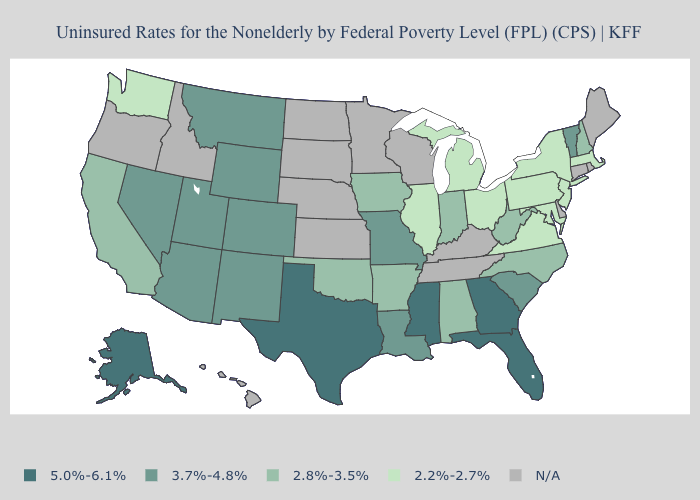Name the states that have a value in the range 3.7%-4.8%?
Short answer required. Arizona, Colorado, Louisiana, Missouri, Montana, Nevada, New Mexico, South Carolina, Utah, Vermont, Wyoming. Name the states that have a value in the range 2.2%-2.7%?
Short answer required. Illinois, Maryland, Massachusetts, Michigan, New Jersey, New York, Ohio, Pennsylvania, Virginia, Washington. What is the highest value in states that border Massachusetts?
Give a very brief answer. 3.7%-4.8%. What is the value of Connecticut?
Give a very brief answer. N/A. Does Colorado have the lowest value in the USA?
Give a very brief answer. No. Does Utah have the lowest value in the West?
Keep it brief. No. Which states have the highest value in the USA?
Concise answer only. Alaska, Florida, Georgia, Mississippi, Texas. Name the states that have a value in the range N/A?
Write a very short answer. Connecticut, Delaware, Hawaii, Idaho, Kansas, Kentucky, Maine, Minnesota, Nebraska, North Dakota, Oregon, Rhode Island, South Dakota, Tennessee, Wisconsin. Is the legend a continuous bar?
Write a very short answer. No. Name the states that have a value in the range 3.7%-4.8%?
Answer briefly. Arizona, Colorado, Louisiana, Missouri, Montana, Nevada, New Mexico, South Carolina, Utah, Vermont, Wyoming. Name the states that have a value in the range 2.8%-3.5%?
Short answer required. Alabama, Arkansas, California, Indiana, Iowa, New Hampshire, North Carolina, Oklahoma, West Virginia. Name the states that have a value in the range 2.2%-2.7%?
Write a very short answer. Illinois, Maryland, Massachusetts, Michigan, New Jersey, New York, Ohio, Pennsylvania, Virginia, Washington. Does Washington have the highest value in the West?
Concise answer only. No. Does Iowa have the lowest value in the MidWest?
Quick response, please. No. What is the lowest value in the South?
Quick response, please. 2.2%-2.7%. 